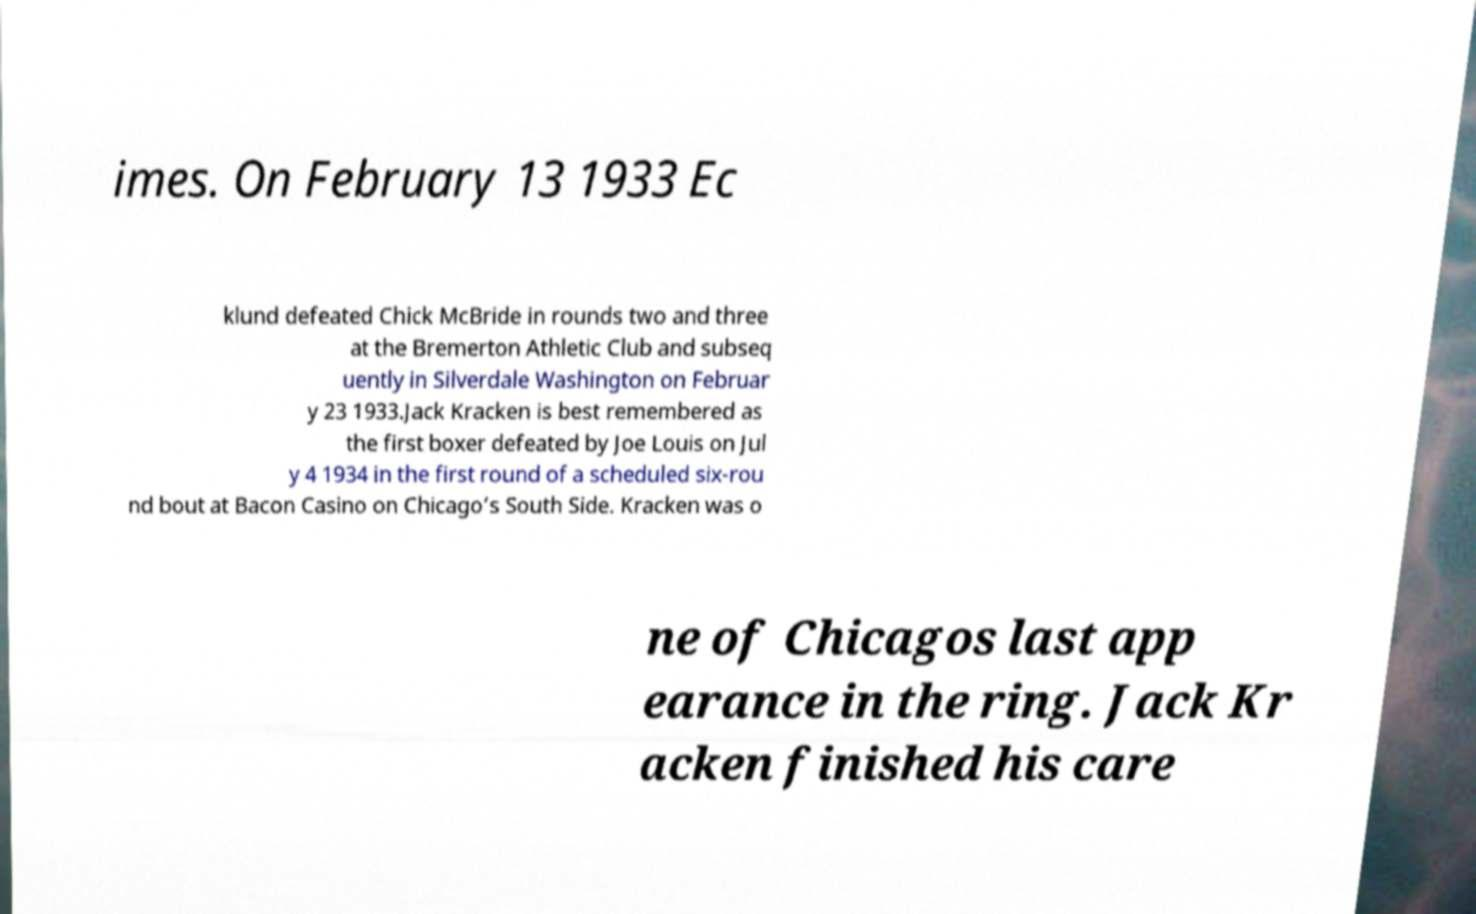Please read and relay the text visible in this image. What does it say? imes. On February 13 1933 Ec klund defeated Chick McBride in rounds two and three at the Bremerton Athletic Club and subseq uently in Silverdale Washington on Februar y 23 1933.Jack Kracken is best remembered as the first boxer defeated by Joe Louis on Jul y 4 1934 in the first round of a scheduled six-rou nd bout at Bacon Casino on Chicago’s South Side. Kracken was o ne of Chicagos last app earance in the ring. Jack Kr acken finished his care 